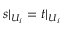Convert formula to latex. <formula><loc_0><loc_0><loc_500><loc_500>s | _ { U _ { i } } = t | _ { U _ { i } }</formula> 